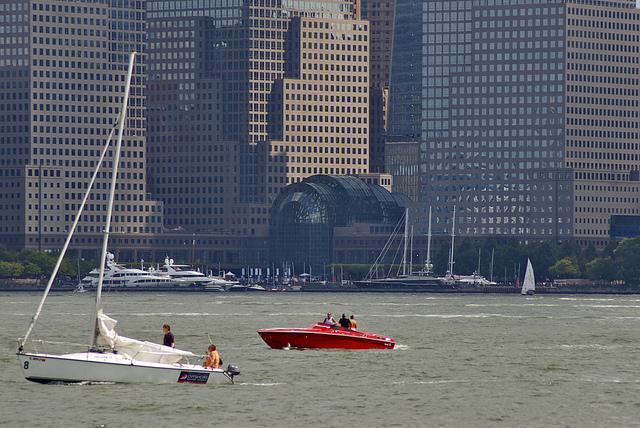How many boats are in the photo?
Give a very brief answer. 3. 